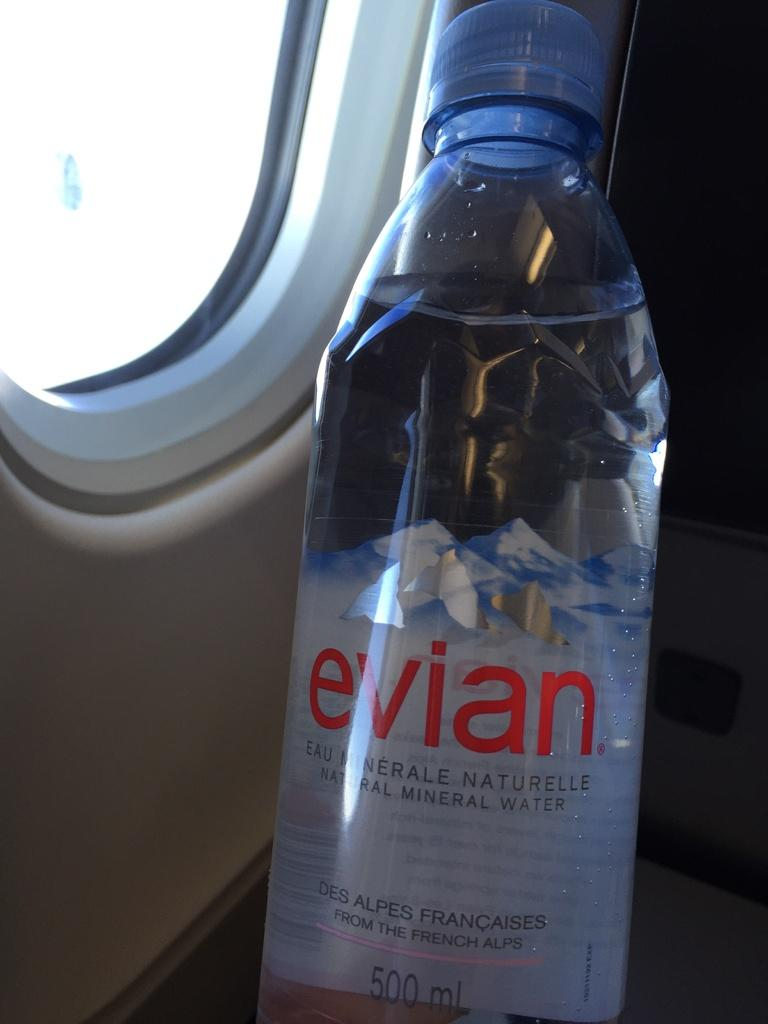What object can be seen in the image related to hydration? There is a water bottle in the image. How far away is the crime scene from the location of the image? There is no crime scene or any indication of a crime in the image, so it is not possible to determine the distance. 